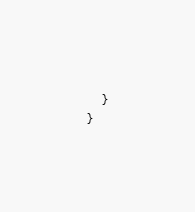<code> <loc_0><loc_0><loc_500><loc_500><_C#_>    }
}
</code> 